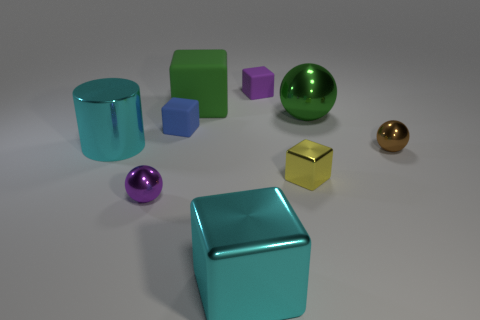Subtract all small purple rubber blocks. How many blocks are left? 4 Subtract 1 cylinders. How many cylinders are left? 0 Subtract all cyan blocks. How many blocks are left? 4 Add 1 blue blocks. How many blue blocks are left? 2 Add 5 cyan metal things. How many cyan metal things exist? 7 Subtract 1 purple balls. How many objects are left? 8 Subtract all cubes. How many objects are left? 4 Subtract all green cubes. Subtract all gray cylinders. How many cubes are left? 4 Subtract all cyan cubes. How many red spheres are left? 0 Subtract all large metallic balls. Subtract all small purple balls. How many objects are left? 7 